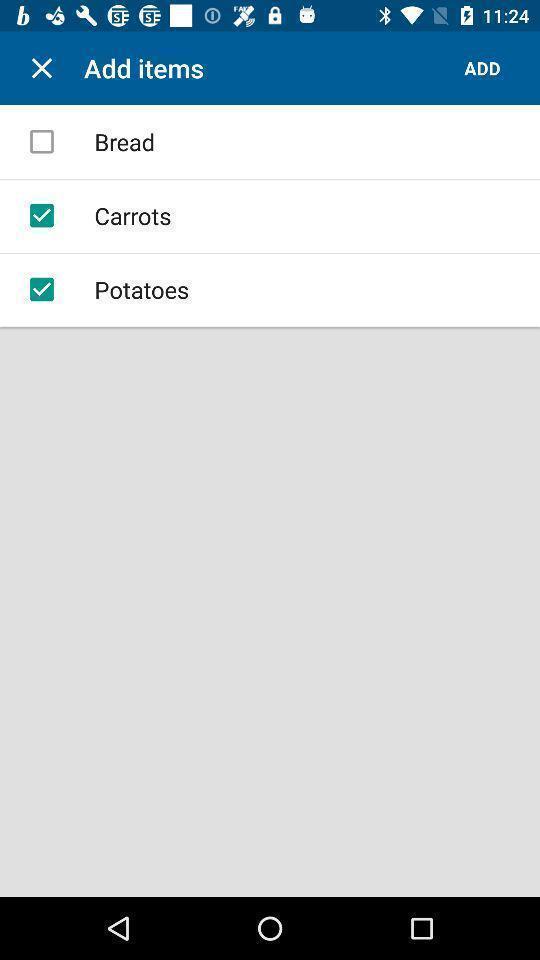Please provide a description for this image. Page displaying to add items. 